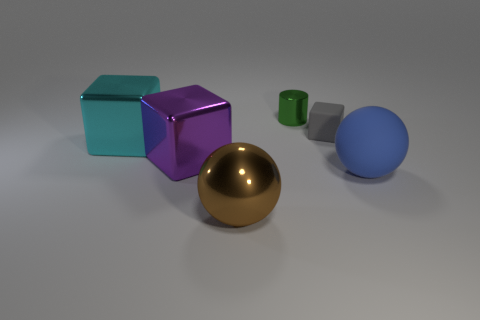Are there the same number of cyan blocks that are on the right side of the tiny gray thing and big brown objects that are behind the large purple block?
Your answer should be very brief. Yes. Are the large ball in front of the rubber ball and the big blue thing made of the same material?
Your answer should be compact. No. What is the color of the cube that is both right of the cyan metallic cube and left of the green cylinder?
Keep it short and to the point. Purple. There is a small object behind the small rubber block; how many cubes are on the left side of it?
Your answer should be very brief. 2. There is a gray object that is the same shape as the cyan shiny object; what is its material?
Give a very brief answer. Rubber. The small shiny cylinder is what color?
Your answer should be very brief. Green. What number of objects are brown things or large blue things?
Ensure brevity in your answer.  2. There is a cyan object that is to the left of the object behind the small rubber block; what is its shape?
Offer a very short reply. Cube. What number of other things are there of the same material as the big blue object
Provide a short and direct response. 1. Are the large cyan object and the ball that is left of the blue ball made of the same material?
Offer a terse response. Yes. 